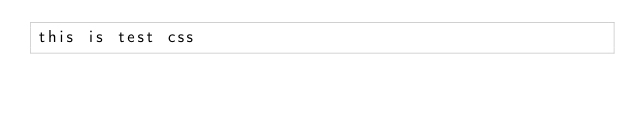<code> <loc_0><loc_0><loc_500><loc_500><_CSS_>this is test css</code> 